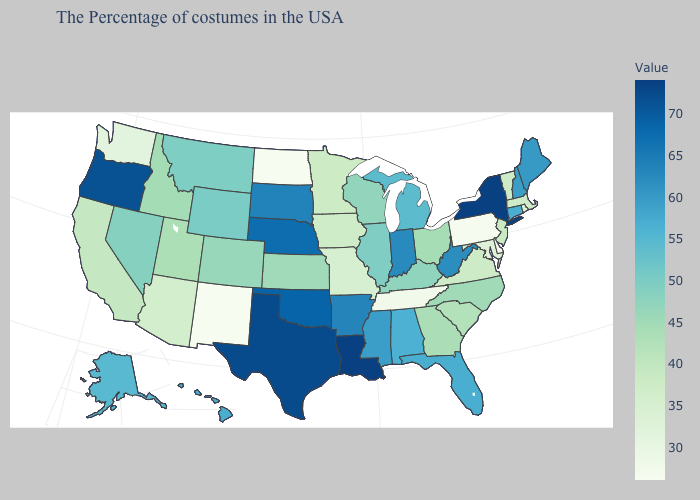Does New Mexico have the lowest value in the West?
Short answer required. Yes. Which states have the highest value in the USA?
Quick response, please. New York, Louisiana. Among the states that border Oregon , which have the lowest value?
Answer briefly. Washington. Which states have the lowest value in the MidWest?
Keep it brief. North Dakota. Which states hav the highest value in the South?
Write a very short answer. Louisiana. Does Pennsylvania have a higher value than Maine?
Concise answer only. No. Among the states that border Nebraska , does Missouri have the highest value?
Concise answer only. No. 